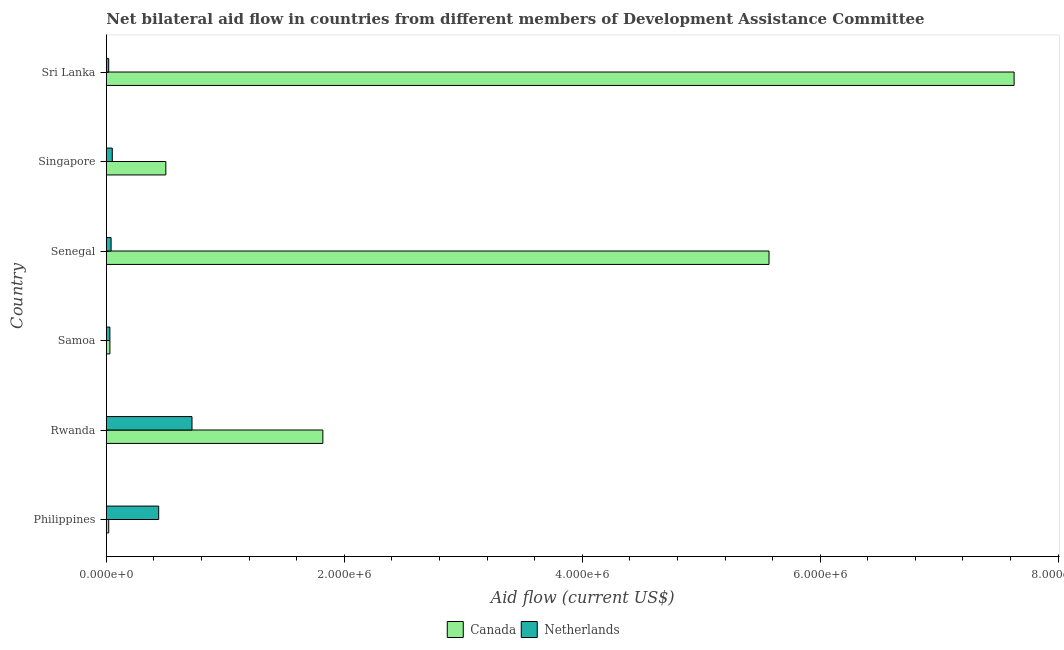How many different coloured bars are there?
Offer a terse response. 2. How many groups of bars are there?
Keep it short and to the point. 6. Are the number of bars on each tick of the Y-axis equal?
Make the answer very short. Yes. How many bars are there on the 1st tick from the bottom?
Offer a very short reply. 2. What is the label of the 2nd group of bars from the top?
Keep it short and to the point. Singapore. What is the amount of aid given by canada in Singapore?
Your response must be concise. 5.00e+05. Across all countries, what is the maximum amount of aid given by netherlands?
Ensure brevity in your answer.  7.20e+05. Across all countries, what is the minimum amount of aid given by netherlands?
Your response must be concise. 2.00e+04. In which country was the amount of aid given by canada maximum?
Make the answer very short. Sri Lanka. In which country was the amount of aid given by canada minimum?
Offer a terse response. Philippines. What is the total amount of aid given by canada in the graph?
Your answer should be compact. 1.56e+07. What is the difference between the amount of aid given by canada in Philippines and that in Rwanda?
Make the answer very short. -1.80e+06. What is the difference between the amount of aid given by canada in Philippines and the amount of aid given by netherlands in Samoa?
Keep it short and to the point. -10000. What is the average amount of aid given by netherlands per country?
Ensure brevity in your answer.  2.17e+05. What is the ratio of the amount of aid given by netherlands in Philippines to that in Senegal?
Your response must be concise. 11. What is the difference between the highest and the lowest amount of aid given by netherlands?
Provide a short and direct response. 7.00e+05. In how many countries, is the amount of aid given by canada greater than the average amount of aid given by canada taken over all countries?
Your answer should be very brief. 2. What does the 1st bar from the bottom in Rwanda represents?
Your response must be concise. Canada. Are all the bars in the graph horizontal?
Give a very brief answer. Yes. How many countries are there in the graph?
Your answer should be compact. 6. What is the difference between two consecutive major ticks on the X-axis?
Your answer should be compact. 2.00e+06. Are the values on the major ticks of X-axis written in scientific E-notation?
Give a very brief answer. Yes. Does the graph contain any zero values?
Offer a very short reply. No. Where does the legend appear in the graph?
Give a very brief answer. Bottom center. How many legend labels are there?
Your answer should be compact. 2. How are the legend labels stacked?
Provide a short and direct response. Horizontal. What is the title of the graph?
Your answer should be compact. Net bilateral aid flow in countries from different members of Development Assistance Committee. Does "Investments" appear as one of the legend labels in the graph?
Provide a short and direct response. No. What is the Aid flow (current US$) of Canada in Rwanda?
Offer a very short reply. 1.82e+06. What is the Aid flow (current US$) in Netherlands in Rwanda?
Provide a short and direct response. 7.20e+05. What is the Aid flow (current US$) in Canada in Samoa?
Offer a terse response. 3.00e+04. What is the Aid flow (current US$) of Canada in Senegal?
Make the answer very short. 5.57e+06. What is the Aid flow (current US$) of Netherlands in Singapore?
Your answer should be compact. 5.00e+04. What is the Aid flow (current US$) in Canada in Sri Lanka?
Your answer should be compact. 7.63e+06. Across all countries, what is the maximum Aid flow (current US$) of Canada?
Make the answer very short. 7.63e+06. Across all countries, what is the maximum Aid flow (current US$) of Netherlands?
Your answer should be very brief. 7.20e+05. Across all countries, what is the minimum Aid flow (current US$) in Netherlands?
Give a very brief answer. 2.00e+04. What is the total Aid flow (current US$) of Canada in the graph?
Your answer should be compact. 1.56e+07. What is the total Aid flow (current US$) in Netherlands in the graph?
Provide a short and direct response. 1.30e+06. What is the difference between the Aid flow (current US$) of Canada in Philippines and that in Rwanda?
Give a very brief answer. -1.80e+06. What is the difference between the Aid flow (current US$) of Netherlands in Philippines and that in Rwanda?
Offer a very short reply. -2.80e+05. What is the difference between the Aid flow (current US$) in Canada in Philippines and that in Samoa?
Offer a very short reply. -10000. What is the difference between the Aid flow (current US$) of Netherlands in Philippines and that in Samoa?
Keep it short and to the point. 4.10e+05. What is the difference between the Aid flow (current US$) of Canada in Philippines and that in Senegal?
Offer a terse response. -5.55e+06. What is the difference between the Aid flow (current US$) in Canada in Philippines and that in Singapore?
Your answer should be very brief. -4.80e+05. What is the difference between the Aid flow (current US$) in Canada in Philippines and that in Sri Lanka?
Offer a terse response. -7.61e+06. What is the difference between the Aid flow (current US$) of Canada in Rwanda and that in Samoa?
Your answer should be very brief. 1.79e+06. What is the difference between the Aid flow (current US$) of Netherlands in Rwanda and that in Samoa?
Give a very brief answer. 6.90e+05. What is the difference between the Aid flow (current US$) of Canada in Rwanda and that in Senegal?
Your response must be concise. -3.75e+06. What is the difference between the Aid flow (current US$) in Netherlands in Rwanda and that in Senegal?
Your response must be concise. 6.80e+05. What is the difference between the Aid flow (current US$) of Canada in Rwanda and that in Singapore?
Provide a short and direct response. 1.32e+06. What is the difference between the Aid flow (current US$) in Netherlands in Rwanda and that in Singapore?
Provide a succinct answer. 6.70e+05. What is the difference between the Aid flow (current US$) in Canada in Rwanda and that in Sri Lanka?
Ensure brevity in your answer.  -5.81e+06. What is the difference between the Aid flow (current US$) in Netherlands in Rwanda and that in Sri Lanka?
Provide a short and direct response. 7.00e+05. What is the difference between the Aid flow (current US$) in Canada in Samoa and that in Senegal?
Provide a succinct answer. -5.54e+06. What is the difference between the Aid flow (current US$) in Canada in Samoa and that in Singapore?
Your answer should be compact. -4.70e+05. What is the difference between the Aid flow (current US$) in Canada in Samoa and that in Sri Lanka?
Make the answer very short. -7.60e+06. What is the difference between the Aid flow (current US$) in Netherlands in Samoa and that in Sri Lanka?
Keep it short and to the point. 10000. What is the difference between the Aid flow (current US$) in Canada in Senegal and that in Singapore?
Keep it short and to the point. 5.07e+06. What is the difference between the Aid flow (current US$) in Netherlands in Senegal and that in Singapore?
Provide a succinct answer. -10000. What is the difference between the Aid flow (current US$) of Canada in Senegal and that in Sri Lanka?
Give a very brief answer. -2.06e+06. What is the difference between the Aid flow (current US$) in Canada in Singapore and that in Sri Lanka?
Offer a terse response. -7.13e+06. What is the difference between the Aid flow (current US$) in Netherlands in Singapore and that in Sri Lanka?
Your response must be concise. 3.00e+04. What is the difference between the Aid flow (current US$) of Canada in Philippines and the Aid flow (current US$) of Netherlands in Rwanda?
Your answer should be very brief. -7.00e+05. What is the difference between the Aid flow (current US$) in Canada in Philippines and the Aid flow (current US$) in Netherlands in Samoa?
Offer a terse response. -10000. What is the difference between the Aid flow (current US$) of Canada in Philippines and the Aid flow (current US$) of Netherlands in Senegal?
Offer a terse response. -2.00e+04. What is the difference between the Aid flow (current US$) in Canada in Philippines and the Aid flow (current US$) in Netherlands in Singapore?
Your answer should be very brief. -3.00e+04. What is the difference between the Aid flow (current US$) of Canada in Philippines and the Aid flow (current US$) of Netherlands in Sri Lanka?
Your answer should be very brief. 0. What is the difference between the Aid flow (current US$) in Canada in Rwanda and the Aid flow (current US$) in Netherlands in Samoa?
Your response must be concise. 1.79e+06. What is the difference between the Aid flow (current US$) in Canada in Rwanda and the Aid flow (current US$) in Netherlands in Senegal?
Your answer should be very brief. 1.78e+06. What is the difference between the Aid flow (current US$) of Canada in Rwanda and the Aid flow (current US$) of Netherlands in Singapore?
Your answer should be compact. 1.77e+06. What is the difference between the Aid flow (current US$) of Canada in Rwanda and the Aid flow (current US$) of Netherlands in Sri Lanka?
Your answer should be very brief. 1.80e+06. What is the difference between the Aid flow (current US$) of Canada in Samoa and the Aid flow (current US$) of Netherlands in Senegal?
Your answer should be compact. -10000. What is the difference between the Aid flow (current US$) in Canada in Samoa and the Aid flow (current US$) in Netherlands in Singapore?
Provide a short and direct response. -2.00e+04. What is the difference between the Aid flow (current US$) of Canada in Samoa and the Aid flow (current US$) of Netherlands in Sri Lanka?
Give a very brief answer. 10000. What is the difference between the Aid flow (current US$) of Canada in Senegal and the Aid flow (current US$) of Netherlands in Singapore?
Offer a very short reply. 5.52e+06. What is the difference between the Aid flow (current US$) in Canada in Senegal and the Aid flow (current US$) in Netherlands in Sri Lanka?
Your answer should be compact. 5.55e+06. What is the difference between the Aid flow (current US$) of Canada in Singapore and the Aid flow (current US$) of Netherlands in Sri Lanka?
Your answer should be very brief. 4.80e+05. What is the average Aid flow (current US$) in Canada per country?
Make the answer very short. 2.60e+06. What is the average Aid flow (current US$) of Netherlands per country?
Your answer should be compact. 2.17e+05. What is the difference between the Aid flow (current US$) of Canada and Aid flow (current US$) of Netherlands in Philippines?
Give a very brief answer. -4.20e+05. What is the difference between the Aid flow (current US$) of Canada and Aid flow (current US$) of Netherlands in Rwanda?
Give a very brief answer. 1.10e+06. What is the difference between the Aid flow (current US$) in Canada and Aid flow (current US$) in Netherlands in Senegal?
Provide a succinct answer. 5.53e+06. What is the difference between the Aid flow (current US$) of Canada and Aid flow (current US$) of Netherlands in Sri Lanka?
Provide a succinct answer. 7.61e+06. What is the ratio of the Aid flow (current US$) in Canada in Philippines to that in Rwanda?
Ensure brevity in your answer.  0.01. What is the ratio of the Aid flow (current US$) of Netherlands in Philippines to that in Rwanda?
Offer a terse response. 0.61. What is the ratio of the Aid flow (current US$) in Canada in Philippines to that in Samoa?
Make the answer very short. 0.67. What is the ratio of the Aid flow (current US$) in Netherlands in Philippines to that in Samoa?
Make the answer very short. 14.67. What is the ratio of the Aid flow (current US$) in Canada in Philippines to that in Senegal?
Your answer should be very brief. 0. What is the ratio of the Aid flow (current US$) of Netherlands in Philippines to that in Singapore?
Offer a very short reply. 8.8. What is the ratio of the Aid flow (current US$) of Canada in Philippines to that in Sri Lanka?
Provide a short and direct response. 0. What is the ratio of the Aid flow (current US$) of Canada in Rwanda to that in Samoa?
Offer a terse response. 60.67. What is the ratio of the Aid flow (current US$) in Canada in Rwanda to that in Senegal?
Offer a terse response. 0.33. What is the ratio of the Aid flow (current US$) in Canada in Rwanda to that in Singapore?
Provide a succinct answer. 3.64. What is the ratio of the Aid flow (current US$) in Netherlands in Rwanda to that in Singapore?
Keep it short and to the point. 14.4. What is the ratio of the Aid flow (current US$) of Canada in Rwanda to that in Sri Lanka?
Provide a short and direct response. 0.24. What is the ratio of the Aid flow (current US$) of Netherlands in Rwanda to that in Sri Lanka?
Keep it short and to the point. 36. What is the ratio of the Aid flow (current US$) of Canada in Samoa to that in Senegal?
Offer a very short reply. 0.01. What is the ratio of the Aid flow (current US$) in Netherlands in Samoa to that in Senegal?
Give a very brief answer. 0.75. What is the ratio of the Aid flow (current US$) of Canada in Samoa to that in Sri Lanka?
Provide a short and direct response. 0. What is the ratio of the Aid flow (current US$) in Netherlands in Samoa to that in Sri Lanka?
Ensure brevity in your answer.  1.5. What is the ratio of the Aid flow (current US$) of Canada in Senegal to that in Singapore?
Give a very brief answer. 11.14. What is the ratio of the Aid flow (current US$) in Netherlands in Senegal to that in Singapore?
Your response must be concise. 0.8. What is the ratio of the Aid flow (current US$) in Canada in Senegal to that in Sri Lanka?
Keep it short and to the point. 0.73. What is the ratio of the Aid flow (current US$) of Canada in Singapore to that in Sri Lanka?
Your answer should be very brief. 0.07. What is the ratio of the Aid flow (current US$) of Netherlands in Singapore to that in Sri Lanka?
Provide a short and direct response. 2.5. What is the difference between the highest and the second highest Aid flow (current US$) in Canada?
Give a very brief answer. 2.06e+06. What is the difference between the highest and the lowest Aid flow (current US$) of Canada?
Your response must be concise. 7.61e+06. What is the difference between the highest and the lowest Aid flow (current US$) of Netherlands?
Keep it short and to the point. 7.00e+05. 